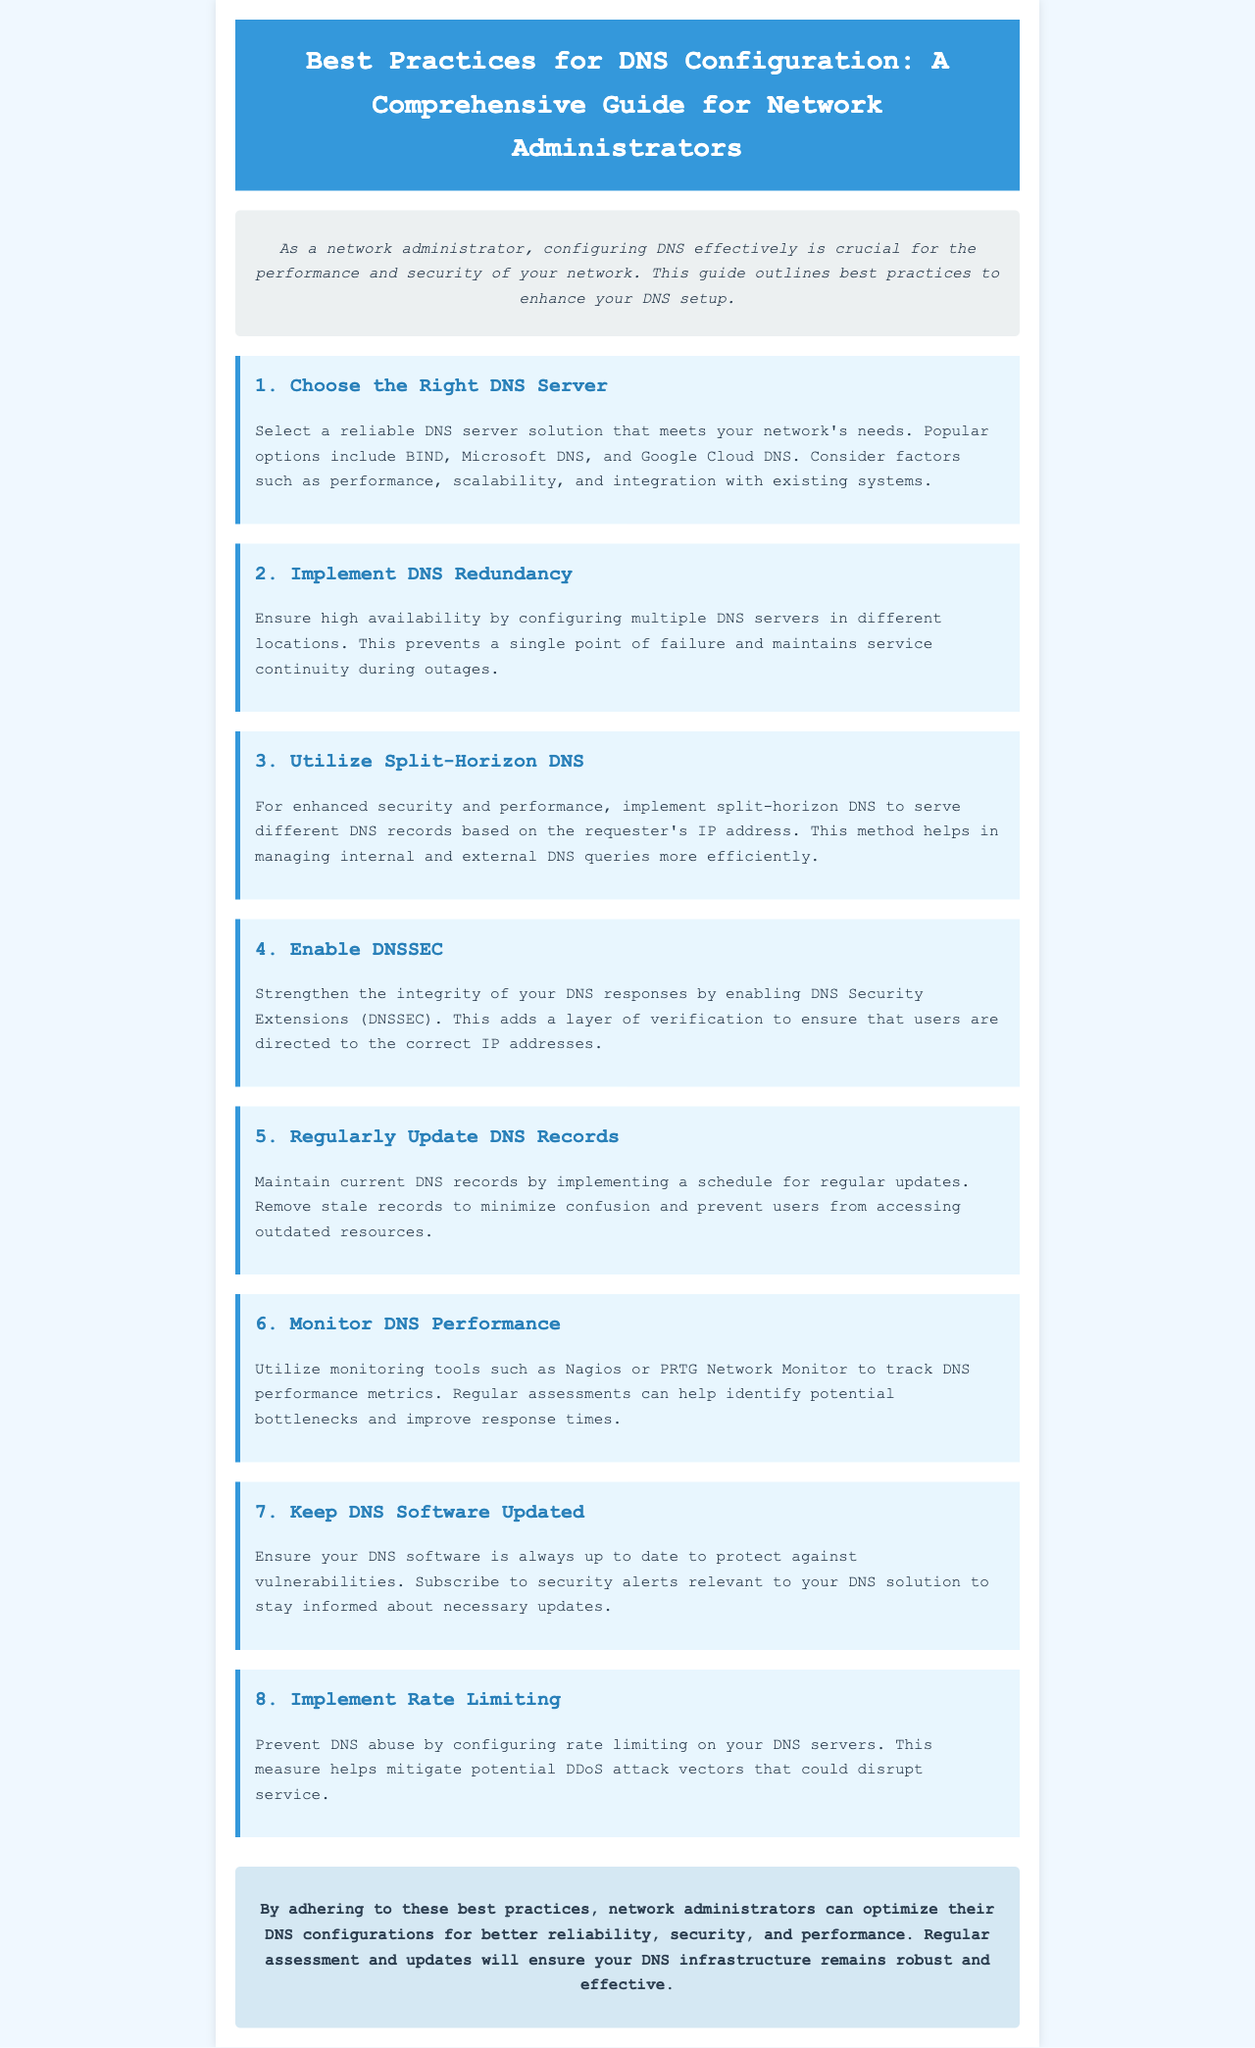What is the main purpose of the newsletter? The newsletter aims to outline best practices for DNS configuration to enhance performance and security for network administrators.
Answer: To enhance performance and security What is the first best practice mentioned in the newsletter? The first best practice listed is selecting a reliable DNS server solution that meets the network's needs.
Answer: Choose the Right DNS Server How many best practices are outlined in the document? The document outlines a total of eight best practices for DNS configuration.
Answer: Eight Which tools are recommended for monitoring DNS performance? The newsletter suggests using tools like Nagios or PRTG Network Monitor to track DNS performance metrics.
Answer: Nagios or PRTG Network Monitor What does DNSSEC stand for? DNSSEC is an abbreviation for DNS Security Extensions.
Answer: DNS Security Extensions Why is implementing DNS redundancy important? Implementing DNS redundancy is crucial to ensure high availability and prevent a single point of failure.
Answer: High availability What should network administrators do with stale DNS records? Administrators should remove stale records to minimize confusion and prevent access to outdated resources.
Answer: Remove stale records What is a benefit of utilizing split-horizon DNS? Split-horizon DNS helps manage internal and external DNS queries more efficiently based on the requester's IP address.
Answer: Manage DNS queries efficiently What type of threats can rate limiting help mitigate? Rate limiting can help mitigate potential DDoS attack vectors that could disrupt DNS service.
Answer: DDoS attacks 